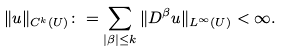<formula> <loc_0><loc_0><loc_500><loc_500>\| u \| _ { C ^ { k } ( U ) } \colon = \sum _ { | \beta | \leq k } \| D ^ { \beta } u \| _ { L ^ { \infty } ( U ) } < \infty .</formula> 